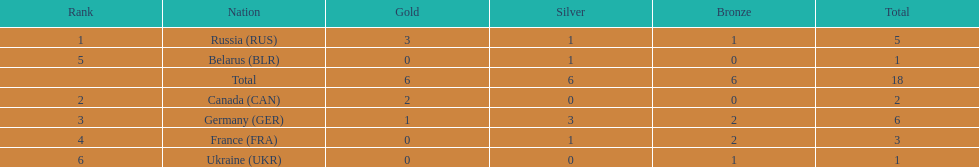What country only received gold medals in the 1994 winter olympics biathlon? Canada (CAN). 